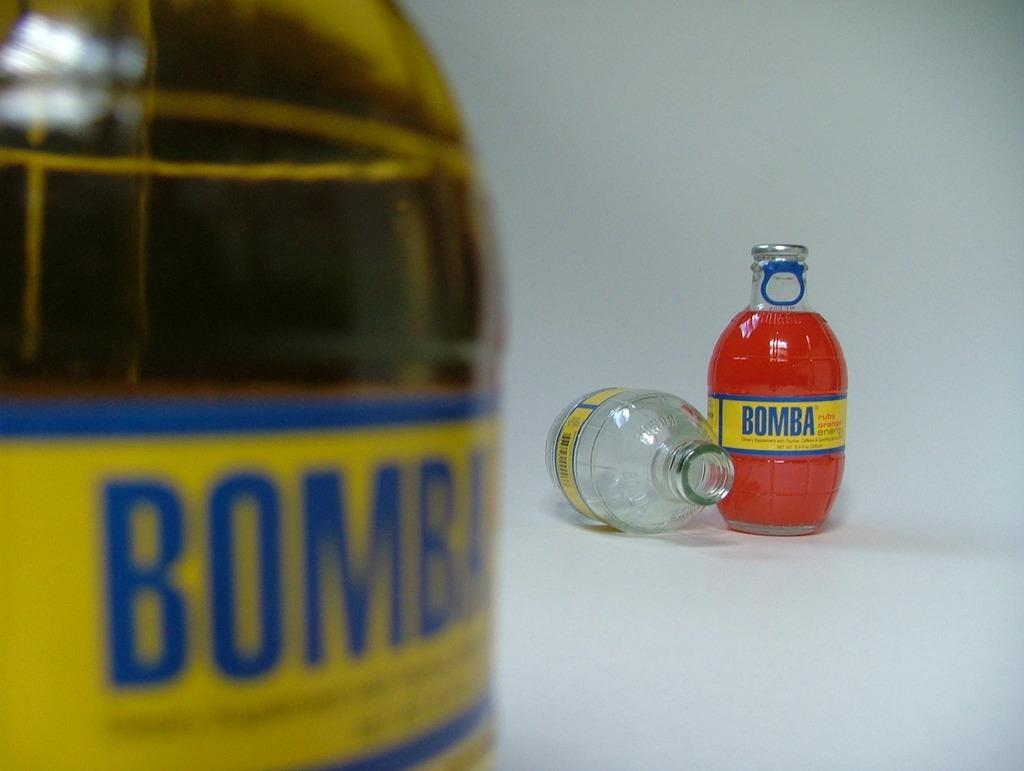Provide a one-sentence caption for the provided image. Two full bottles of Bomba are shown with an empty bottle. 